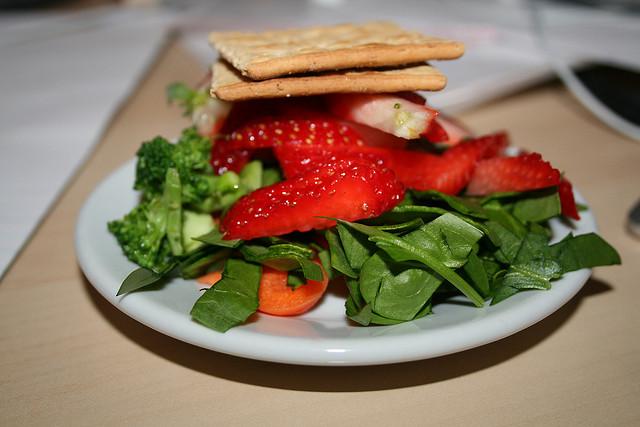Is that clover on top of the food?
Answer briefly. No. What fruit is on the plate?
Concise answer only. Strawberry. Is this a sweet meal?
Be succinct. No. Would this be a fit meal for a vegan?
Quick response, please. Yes. Are there carrots on the plate?
Give a very brief answer. Yes. What is the orange vegetable called?
Concise answer only. Carrot. What is on top of the green leaves?
Quick response, please. Strawberries. Is there tomato in the picture?
Quick response, please. No. What is the red food called?
Write a very short answer. Strawberry. Is this a sandwich?
Answer briefly. No. What are the spices used in the dish?
Quick response, please. Spinach. What type of salad is this?
Short answer required. Strawberry. What is this food called?
Write a very short answer. Salad. Is this a fancy or casual meal?
Be succinct. Casual. Does the salad have dressing?
Be succinct. No. Would you serve this for breakfast or dinner?
Answer briefly. Dinner. Is this food cooked or raw?
Give a very brief answer. Raw. Is there any meat on the plate?
Write a very short answer. No. What type of lettuce is in the sandwich?
Concise answer only. Spinach. What green vegetable is in this bowl?
Short answer required. Spinach. Is this vegetarian friendly?
Short answer required. Yes. Is there fruit in the photo?
Give a very brief answer. Yes. Is there meat in the meal?
Give a very brief answer. No. What is the red food?
Concise answer only. Strawberry. Would a vegan eat this?
Answer briefly. Yes. Is this meal vegan?
Be succinct. Yes. What is the person eating?
Write a very short answer. Salad. Would a vegetarian eat this meal?
Short answer required. Yes. Is this a healthy meal?
Concise answer only. Yes. What is the green vegetable on the pizza?
Short answer required. Spinach. Is there a human present in the picture?
Keep it brief. No. How many sources of protein are in this photo?
Keep it brief. 1. What color is the dressing on the lettuce?
Keep it brief. Clear. Is this a vegetarian meal?
Quick response, please. Yes. What is the red round food?
Be succinct. Strawberries. Are there a lot of calories in this meal?
Answer briefly. No. 